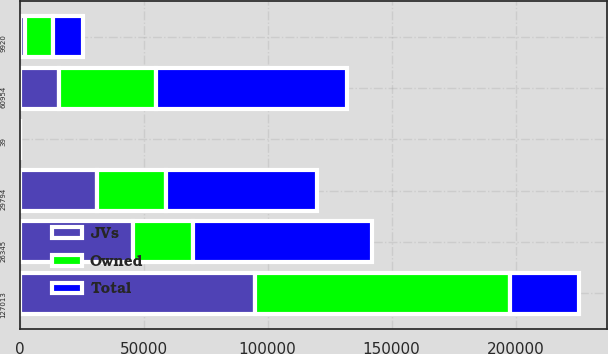Convert chart to OTSL. <chart><loc_0><loc_0><loc_500><loc_500><stacked_bar_chart><ecel><fcel>60954<fcel>29794<fcel>26345<fcel>9920<fcel>127013<fcel>39<nl><fcel>JVs<fcel>15930<fcel>31284<fcel>45609<fcel>2283<fcel>95106<fcel>29<nl><fcel>Total<fcel>76884<fcel>61078<fcel>71954<fcel>12203<fcel>27704<fcel>68<nl><fcel>Owned<fcel>39259<fcel>27704<fcel>24477<fcel>11247<fcel>102687<fcel>32<nl></chart> 